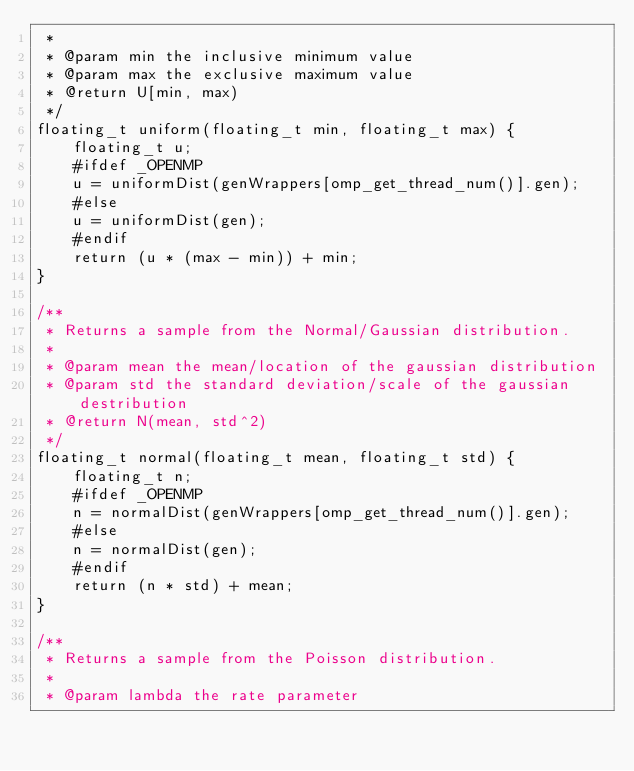Convert code to text. <code><loc_0><loc_0><loc_500><loc_500><_Cuda_> *
 * @param min the inclusive minimum value
 * @param max the exclusive maximum value
 * @return U[min, max)
 */
floating_t uniform(floating_t min, floating_t max) {
    floating_t u;
    #ifdef _OPENMP
    u = uniformDist(genWrappers[omp_get_thread_num()].gen);
    #else
    u = uniformDist(gen);
    #endif
    return (u * (max - min)) + min;
}

/**
 * Returns a sample from the Normal/Gaussian distribution.
 *
 * @param mean the mean/location of the gaussian distribution
 * @param std the standard deviation/scale of the gaussian destribution
 * @return N(mean, std^2)
 */
floating_t normal(floating_t mean, floating_t std) {
    floating_t n;
    #ifdef _OPENMP
    n = normalDist(genWrappers[omp_get_thread_num()].gen);
    #else
    n = normalDist(gen);
    #endif
    return (n * std) + mean;
}

/**
 * Returns a sample from the Poisson distribution.
 *
 * @param lambda the rate parameter</code> 